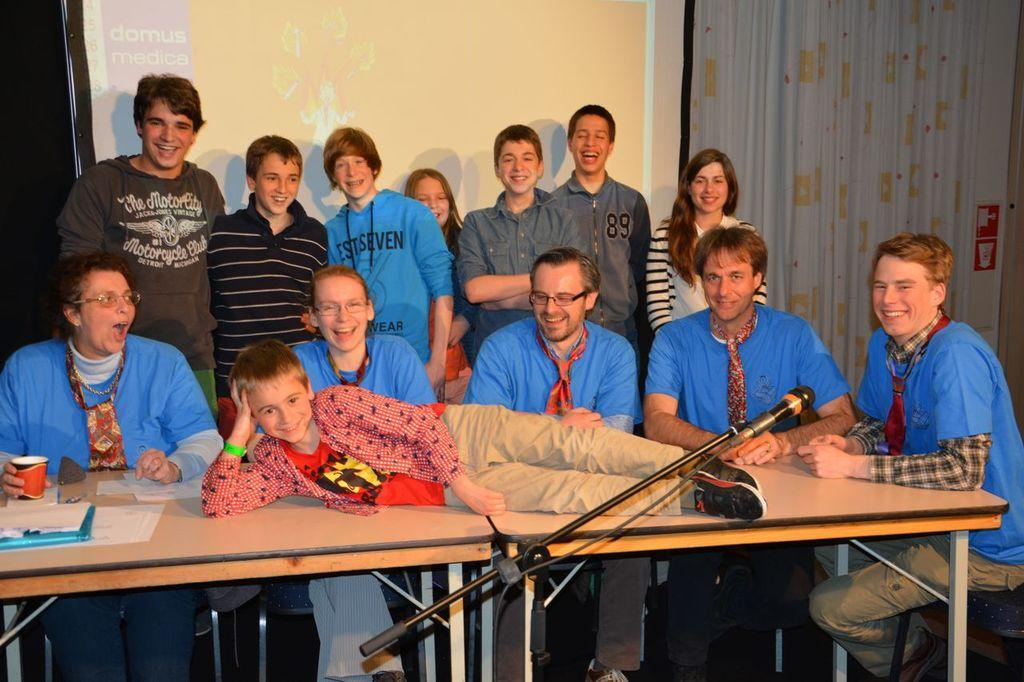What is the position of the boy in the image? The boy is lying on a table in the image. Who is present around the table? There are people around the table in the image. Can you describe the position of the other children in the image? Some boys and girls are standing behind the people around the table. What is the weather like in the image? The provided facts do not mention the weather, so we cannot determine the weather from the image. 